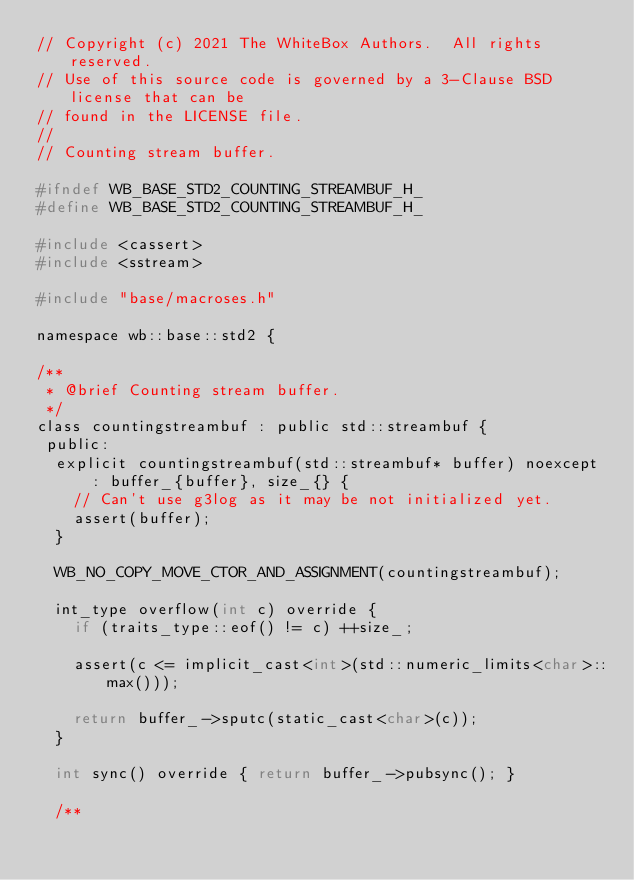<code> <loc_0><loc_0><loc_500><loc_500><_C_>// Copyright (c) 2021 The WhiteBox Authors.  All rights reserved.
// Use of this source code is governed by a 3-Clause BSD license that can be
// found in the LICENSE file.
//
// Counting stream buffer.

#ifndef WB_BASE_STD2_COUNTING_STREAMBUF_H_
#define WB_BASE_STD2_COUNTING_STREAMBUF_H_

#include <cassert>
#include <sstream>

#include "base/macroses.h"

namespace wb::base::std2 {

/**
 * @brief Counting stream buffer.
 */
class countingstreambuf : public std::streambuf {
 public:
  explicit countingstreambuf(std::streambuf* buffer) noexcept
      : buffer_{buffer}, size_{} {
    // Can't use g3log as it may be not initialized yet.
    assert(buffer);
  }

  WB_NO_COPY_MOVE_CTOR_AND_ASSIGNMENT(countingstreambuf);

  int_type overflow(int c) override {
    if (traits_type::eof() != c) ++size_;

    assert(c <= implicit_cast<int>(std::numeric_limits<char>::max()));

    return buffer_->sputc(static_cast<char>(c));
  }

  int sync() override { return buffer_->pubsync(); }

  /**</code> 